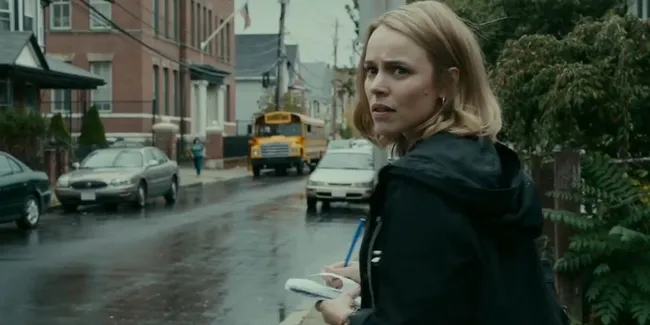Imagine this scene is from a sci-fi movie. Describe it with that context. In a dystopian future where the sky is perpetually overcast and the rain never ceases, Dr. Evelyn Hart stands on a dilapidated street, the remnant of a once-thriving urban center. Clutching a holo-communicator instead of a conventional phone, she scans her surroundings. The yellow school bus behind her is an ancient relic from a long-forgotten era, now repurposed for transporting vital supplies. The red-brick buildings, partially obscured by overgrown vegetation, hint at nature reclaiming the abandoned cityscape. Dr. Hart’s mission is critical; she’s on the brink of discovering a breakthrough that could save humanity. Her determined gaze reflects the weight of her task as she prepares to rendezvous with her team, knowing that every second counts in this race against time. If the woman were a time traveler from the future observing the past, what might she be thinking? As a time traveler from the future, the woman's mind would be inundated with contrasting images of her advanced world and the simplicity of 21st-century life. She might be thinking about how this era's technology, reflected in the mundane white phone and the yellow school bus, once laid the foundation for more unimaginable advancements. Observing the red-brick buildings and the familiar urban scene, she could be contemplating the choices humanity made that led to her present - both the triumphs and the mistakes. There’s a mix of nostalgia and urgency in her expression, knowing the importance of observing these nuances without altering the timeline. Her mission is delicate, requiring her not only to study but also to appreciate the world that ultimately shaped her own. 